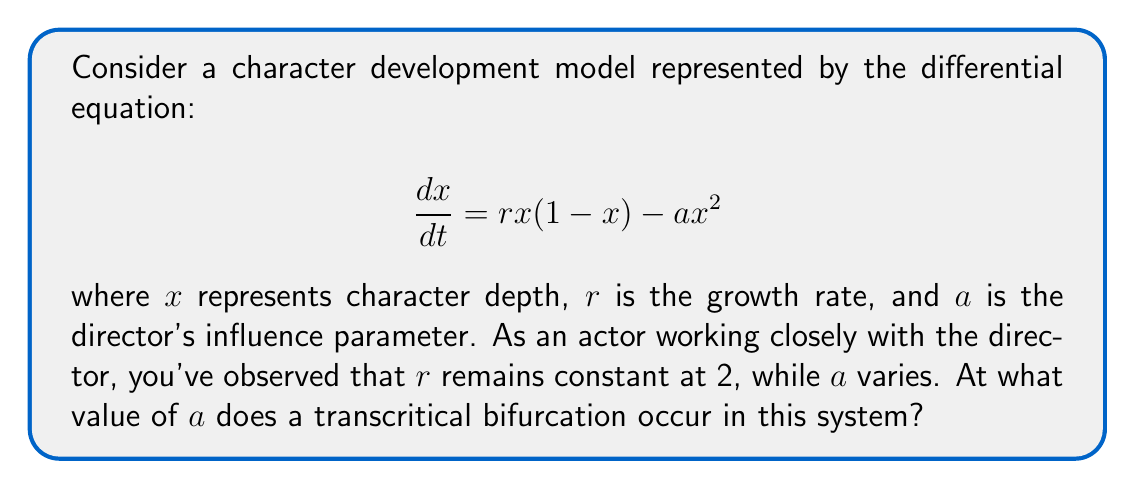Help me with this question. To find the transcritical bifurcation point, we need to follow these steps:

1) First, find the equilibrium points of the system by setting $\frac{dx}{dt} = 0$:

   $$rx(1-x) - ax^2 = 0$$
   $$2x(1-x) - ax^2 = 0$$
   $$2x - 2x^2 - ax^2 = 0$$
   $$x(2 - 2x - ax) = 0$$

2) This gives us two equilibrium points:
   $x_1 = 0$ and $x_2 = \frac{2-a}{2}$

3) A transcritical bifurcation occurs when these two equilibrium points exchange stability. This happens when they coincide, i.e., when $x_2 = x_1 = 0$.

4) Set $x_2 = 0$:

   $$\frac{2-a}{2} = 0$$
   $$2-a = 0$$
   $$a = 2$$

5) To confirm this is indeed a transcritical bifurcation, we can check the stability of the equilibrium points:

   For $x_1 = 0$:
   $$\frac{d}{dx}(rx(1-x) - ax^2)|_{x=0} = r = 2$$

   For $x_2 = \frac{2-a}{2}$:
   $$\frac{d}{dx}(rx(1-x) - ax^2)|_{x=\frac{2-a}{2}} = -(2-a)$$

   When $a < 2$, $x_1$ is unstable and $x_2$ is stable.
   When $a > 2$, $x_1$ is stable and $x_2$ is unstable.
   At $a = 2$, they exchange stability, confirming a transcritical bifurcation.

Therefore, the transcritical bifurcation occurs when $a = 2$.
Answer: $a = 2$ 